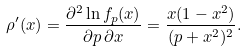Convert formula to latex. <formula><loc_0><loc_0><loc_500><loc_500>\rho ^ { \prime } ( x ) = \frac { \partial ^ { 2 } \ln f _ { p } ( x ) } { \partial p \, \partial x } = \frac { x ( 1 - x ^ { 2 } ) } { ( p + x ^ { 2 } ) ^ { 2 } } .</formula> 